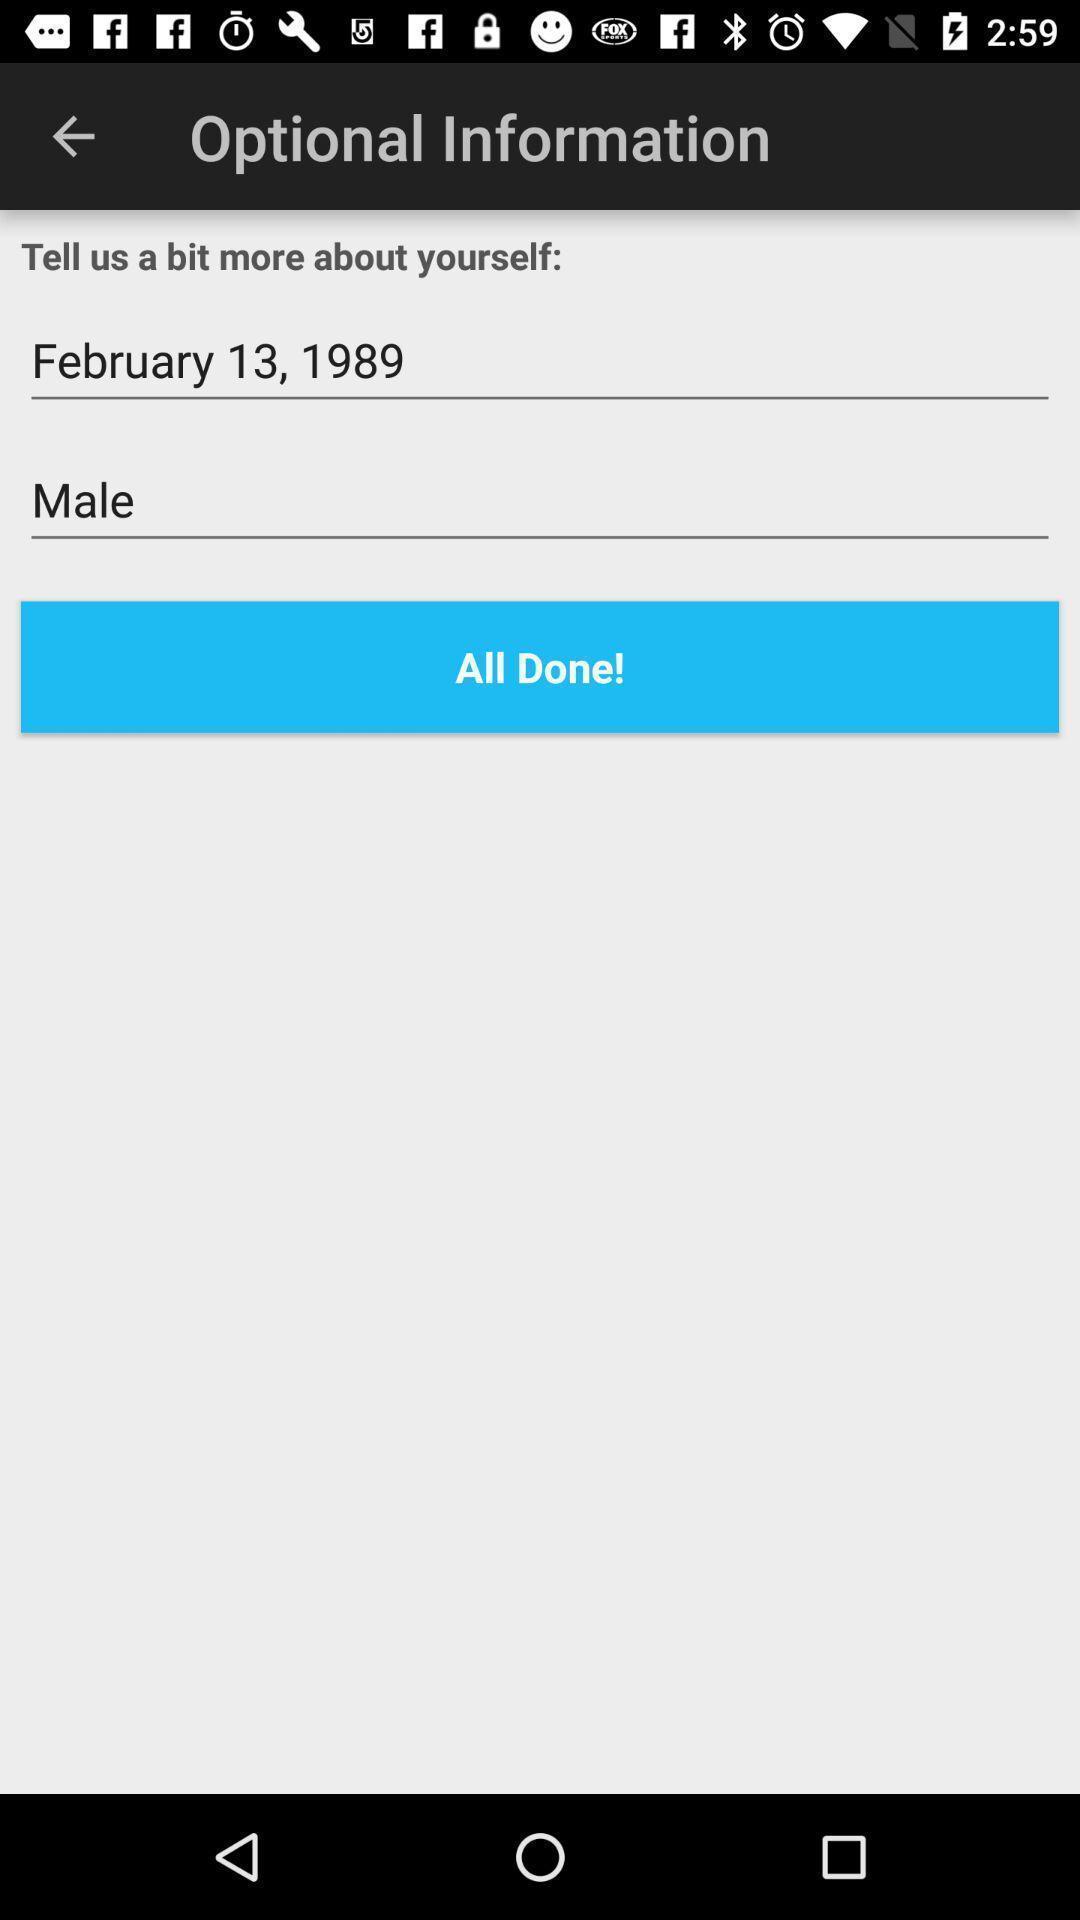What can you discern from this picture? Screen displaying user information. 